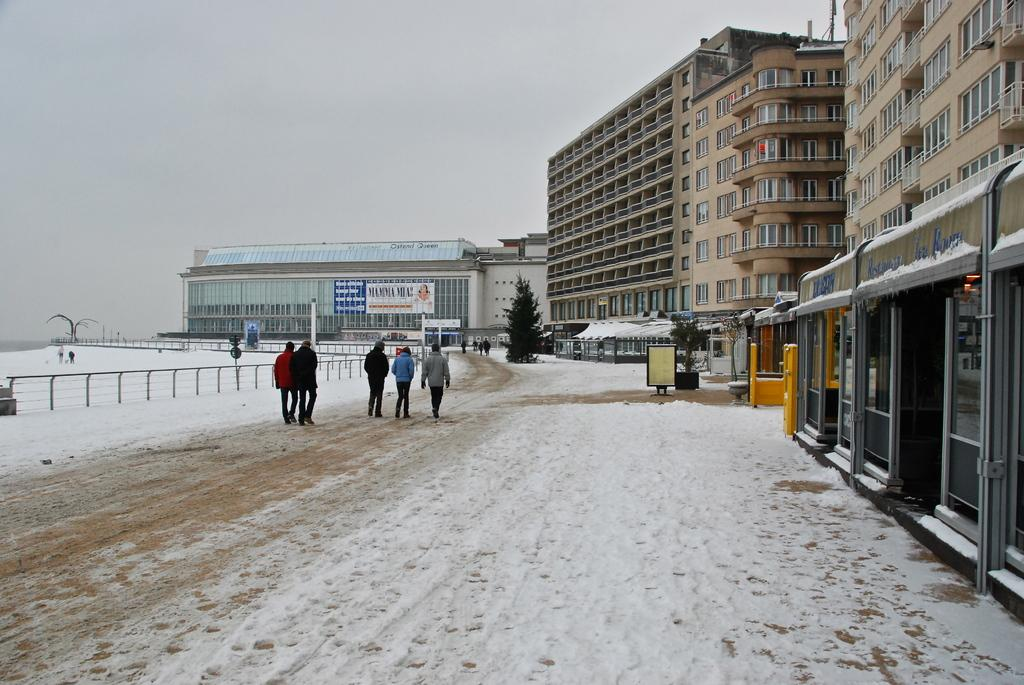What are the people in the image doing? People are walking in the image. What can be seen in the background of the image? There is fencing and buildings in the image. What is the weather like in the image? There is snow in the image, indicating a cold or wintry weather. How many horses are visible in the image? There are no horses present in the image. What type of channel can be seen running through the buildings in the image? There is no channel visible in the image; it only features people walking, fencing, and buildings. 